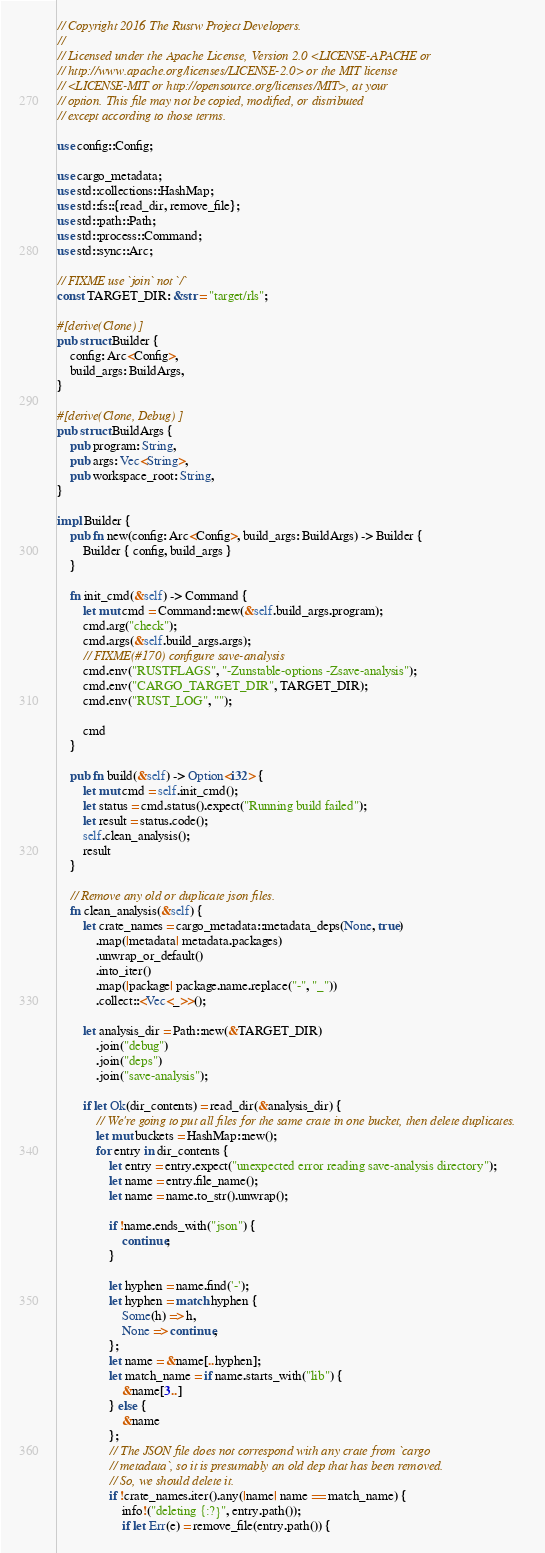<code> <loc_0><loc_0><loc_500><loc_500><_Rust_>// Copyright 2016 The Rustw Project Developers.
//
// Licensed under the Apache License, Version 2.0 <LICENSE-APACHE or
// http://www.apache.org/licenses/LICENSE-2.0> or the MIT license
// <LICENSE-MIT or http://opensource.org/licenses/MIT>, at your
// option. This file may not be copied, modified, or distributed
// except according to those terms.

use config::Config;

use cargo_metadata;
use std::collections::HashMap;
use std::fs::{read_dir, remove_file};
use std::path::Path;
use std::process::Command;
use std::sync::Arc;

// FIXME use `join` not `/`
const TARGET_DIR: &str = "target/rls";

#[derive(Clone)]
pub struct Builder {
    config: Arc<Config>,
    build_args: BuildArgs,
}

#[derive(Clone, Debug)]
pub struct BuildArgs {
    pub program: String,
    pub args: Vec<String>,
    pub workspace_root: String,
}

impl Builder {
    pub fn new(config: Arc<Config>, build_args: BuildArgs) -> Builder {
        Builder { config, build_args }
    }

    fn init_cmd(&self) -> Command {
        let mut cmd = Command::new(&self.build_args.program);
        cmd.arg("check");
        cmd.args(&self.build_args.args);
        // FIXME(#170) configure save-analysis
        cmd.env("RUSTFLAGS", "-Zunstable-options -Zsave-analysis");
        cmd.env("CARGO_TARGET_DIR", TARGET_DIR);
        cmd.env("RUST_LOG", "");

        cmd
    }

    pub fn build(&self) -> Option<i32> {
        let mut cmd = self.init_cmd();
        let status = cmd.status().expect("Running build failed");
        let result = status.code();
        self.clean_analysis();
        result
    }

    // Remove any old or duplicate json files.
    fn clean_analysis(&self) {
        let crate_names = cargo_metadata::metadata_deps(None, true)
            .map(|metadata| metadata.packages)
            .unwrap_or_default()
            .into_iter()
            .map(|package| package.name.replace("-", "_"))
            .collect::<Vec<_>>();

        let analysis_dir = Path::new(&TARGET_DIR)
            .join("debug")
            .join("deps")
            .join("save-analysis");

        if let Ok(dir_contents) = read_dir(&analysis_dir) {
            // We're going to put all files for the same crate in one bucket, then delete duplicates.
            let mut buckets = HashMap::new();
            for entry in dir_contents {
                let entry = entry.expect("unexpected error reading save-analysis directory");
                let name = entry.file_name();
                let name = name.to_str().unwrap();

                if !name.ends_with("json") {
                    continue;
                }

                let hyphen = name.find('-');
                let hyphen = match hyphen {
                    Some(h) => h,
                    None => continue,
                };
                let name = &name[..hyphen];
                let match_name = if name.starts_with("lib") {
                    &name[3..]
                } else {
                    &name
                };
                // The JSON file does not correspond with any crate from `cargo
                // metadata`, so it is presumably an old dep that has been removed.
                // So, we should delete it.
                if !crate_names.iter().any(|name| name == match_name) {
                    info!("deleting {:?}", entry.path());
                    if let Err(e) = remove_file(entry.path()) {</code> 